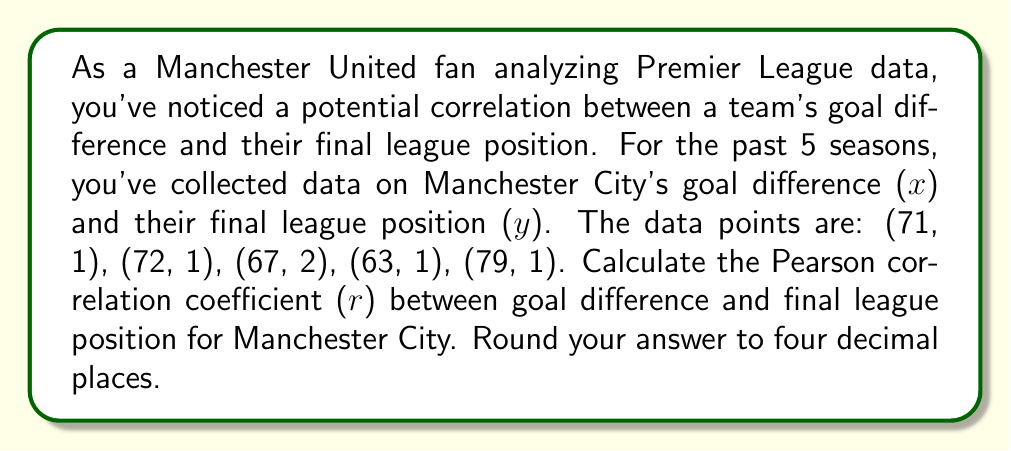What is the answer to this math problem? To calculate the Pearson correlation coefficient (r), we'll use the formula:

$$ r = \frac{n\sum xy - \sum x \sum y}{\sqrt{[n\sum x^2 - (\sum x)^2][n\sum y^2 - (\sum y)^2]}} $$

Where:
n = number of data points
x = goal difference
y = final league position

Step 1: Calculate the sums and squared sums:
$\sum x = 71 + 72 + 67 + 63 + 79 = 352$
$\sum y = 1 + 1 + 2 + 1 + 1 = 6$
$\sum xy = 71(1) + 72(1) + 67(2) + 63(1) + 79(1) = 352$
$\sum x^2 = 71^2 + 72^2 + 67^2 + 63^2 + 79^2 = 24,922$
$\sum y^2 = 1^2 + 1^2 + 2^2 + 1^2 + 1^2 = 8$

Step 2: Substitute these values into the formula:

$$ r = \frac{5(352) - 352(6)}{\sqrt{[5(24,922) - 352^2][5(8) - 6^2]}} $$

Step 3: Simplify:

$$ r = \frac{1760 - 2112}{\sqrt{[124,610 - 123,904][40 - 36]}} $$

$$ r = \frac{-352}{\sqrt{706 * 4}} $$

$$ r = \frac{-352}{\sqrt{2824}} $$

$$ r = \frac{-352}{53.14} $$

$$ r \approx -6.6241 $$

Step 4: Round to four decimal places:

$$ r \approx -0.6624 $$

The negative correlation indicates that as goal difference increases, the league position tends to decrease (improve, as 1st is better than 2nd).
Answer: $-0.6624$ 